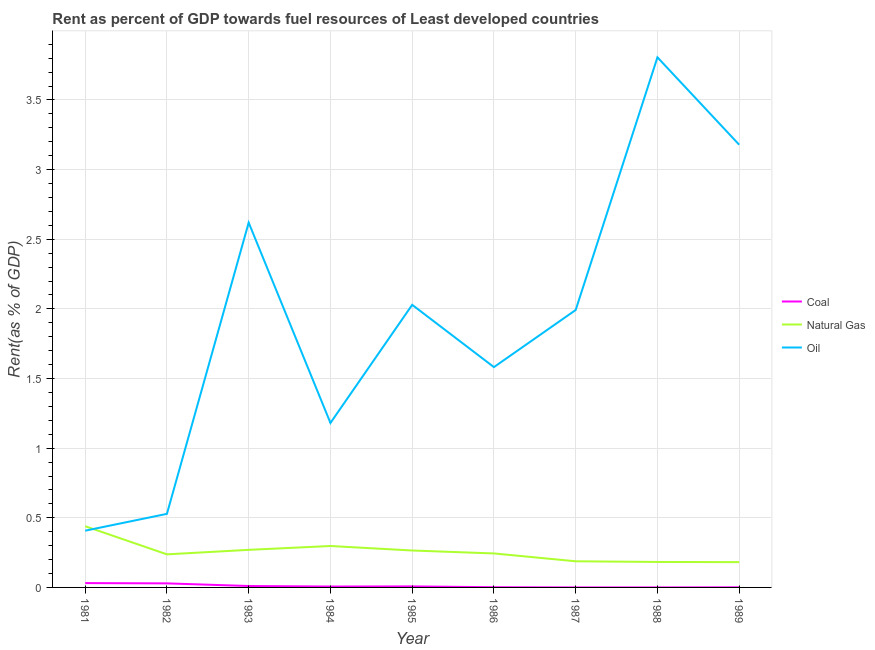How many different coloured lines are there?
Provide a succinct answer. 3. Does the line corresponding to rent towards natural gas intersect with the line corresponding to rent towards coal?
Ensure brevity in your answer.  No. What is the rent towards coal in 1984?
Give a very brief answer. 0.01. Across all years, what is the maximum rent towards coal?
Provide a short and direct response. 0.03. Across all years, what is the minimum rent towards oil?
Ensure brevity in your answer.  0.41. In which year was the rent towards coal maximum?
Keep it short and to the point. 1981. In which year was the rent towards oil minimum?
Your response must be concise. 1981. What is the total rent towards oil in the graph?
Offer a very short reply. 17.32. What is the difference between the rent towards coal in 1982 and that in 1988?
Provide a succinct answer. 0.03. What is the difference between the rent towards coal in 1981 and the rent towards natural gas in 1988?
Your answer should be compact. -0.15. What is the average rent towards natural gas per year?
Your answer should be very brief. 0.26. In the year 1989, what is the difference between the rent towards oil and rent towards natural gas?
Provide a succinct answer. 3. What is the ratio of the rent towards natural gas in 1982 to that in 1989?
Your response must be concise. 1.31. What is the difference between the highest and the second highest rent towards coal?
Offer a terse response. 0. What is the difference between the highest and the lowest rent towards coal?
Your answer should be compact. 0.03. Does the rent towards coal monotonically increase over the years?
Offer a terse response. No. Is the rent towards coal strictly greater than the rent towards natural gas over the years?
Provide a succinct answer. No. How many lines are there?
Make the answer very short. 3. How many years are there in the graph?
Keep it short and to the point. 9. Are the values on the major ticks of Y-axis written in scientific E-notation?
Your answer should be compact. No. Does the graph contain grids?
Give a very brief answer. Yes. Where does the legend appear in the graph?
Ensure brevity in your answer.  Center right. What is the title of the graph?
Give a very brief answer. Rent as percent of GDP towards fuel resources of Least developed countries. What is the label or title of the X-axis?
Offer a very short reply. Year. What is the label or title of the Y-axis?
Provide a short and direct response. Rent(as % of GDP). What is the Rent(as % of GDP) of Coal in 1981?
Your answer should be very brief. 0.03. What is the Rent(as % of GDP) of Natural Gas in 1981?
Ensure brevity in your answer.  0.44. What is the Rent(as % of GDP) of Oil in 1981?
Your response must be concise. 0.41. What is the Rent(as % of GDP) of Coal in 1982?
Your answer should be compact. 0.03. What is the Rent(as % of GDP) of Natural Gas in 1982?
Offer a terse response. 0.24. What is the Rent(as % of GDP) of Oil in 1982?
Provide a short and direct response. 0.53. What is the Rent(as % of GDP) of Coal in 1983?
Your answer should be very brief. 0.01. What is the Rent(as % of GDP) in Natural Gas in 1983?
Make the answer very short. 0.27. What is the Rent(as % of GDP) of Oil in 1983?
Your answer should be compact. 2.62. What is the Rent(as % of GDP) of Coal in 1984?
Provide a short and direct response. 0.01. What is the Rent(as % of GDP) in Natural Gas in 1984?
Your answer should be very brief. 0.3. What is the Rent(as % of GDP) of Oil in 1984?
Offer a very short reply. 1.18. What is the Rent(as % of GDP) of Coal in 1985?
Offer a very short reply. 0.01. What is the Rent(as % of GDP) in Natural Gas in 1985?
Offer a very short reply. 0.27. What is the Rent(as % of GDP) in Oil in 1985?
Your answer should be very brief. 2.03. What is the Rent(as % of GDP) in Coal in 1986?
Make the answer very short. 0. What is the Rent(as % of GDP) of Natural Gas in 1986?
Your answer should be very brief. 0.24. What is the Rent(as % of GDP) in Oil in 1986?
Keep it short and to the point. 1.58. What is the Rent(as % of GDP) of Coal in 1987?
Offer a terse response. 5.84697420507121e-6. What is the Rent(as % of GDP) in Natural Gas in 1987?
Give a very brief answer. 0.19. What is the Rent(as % of GDP) of Oil in 1987?
Your answer should be compact. 1.99. What is the Rent(as % of GDP) of Coal in 1988?
Offer a terse response. 1.03994551316466e-5. What is the Rent(as % of GDP) of Natural Gas in 1988?
Give a very brief answer. 0.18. What is the Rent(as % of GDP) of Oil in 1988?
Your answer should be very brief. 3.81. What is the Rent(as % of GDP) in Coal in 1989?
Ensure brevity in your answer.  0. What is the Rent(as % of GDP) in Natural Gas in 1989?
Provide a short and direct response. 0.18. What is the Rent(as % of GDP) in Oil in 1989?
Your answer should be very brief. 3.18. Across all years, what is the maximum Rent(as % of GDP) of Coal?
Ensure brevity in your answer.  0.03. Across all years, what is the maximum Rent(as % of GDP) of Natural Gas?
Offer a very short reply. 0.44. Across all years, what is the maximum Rent(as % of GDP) in Oil?
Offer a very short reply. 3.81. Across all years, what is the minimum Rent(as % of GDP) of Coal?
Give a very brief answer. 5.84697420507121e-6. Across all years, what is the minimum Rent(as % of GDP) of Natural Gas?
Your response must be concise. 0.18. Across all years, what is the minimum Rent(as % of GDP) of Oil?
Provide a short and direct response. 0.41. What is the total Rent(as % of GDP) of Coal in the graph?
Offer a very short reply. 0.09. What is the total Rent(as % of GDP) of Natural Gas in the graph?
Offer a very short reply. 2.31. What is the total Rent(as % of GDP) of Oil in the graph?
Provide a succinct answer. 17.32. What is the difference between the Rent(as % of GDP) in Coal in 1981 and that in 1982?
Give a very brief answer. 0. What is the difference between the Rent(as % of GDP) in Natural Gas in 1981 and that in 1982?
Make the answer very short. 0.2. What is the difference between the Rent(as % of GDP) of Oil in 1981 and that in 1982?
Provide a succinct answer. -0.12. What is the difference between the Rent(as % of GDP) in Coal in 1981 and that in 1983?
Ensure brevity in your answer.  0.02. What is the difference between the Rent(as % of GDP) of Natural Gas in 1981 and that in 1983?
Your response must be concise. 0.17. What is the difference between the Rent(as % of GDP) in Oil in 1981 and that in 1983?
Offer a very short reply. -2.21. What is the difference between the Rent(as % of GDP) in Coal in 1981 and that in 1984?
Give a very brief answer. 0.02. What is the difference between the Rent(as % of GDP) in Natural Gas in 1981 and that in 1984?
Your response must be concise. 0.14. What is the difference between the Rent(as % of GDP) in Oil in 1981 and that in 1984?
Make the answer very short. -0.77. What is the difference between the Rent(as % of GDP) of Coal in 1981 and that in 1985?
Your answer should be very brief. 0.02. What is the difference between the Rent(as % of GDP) in Natural Gas in 1981 and that in 1985?
Your response must be concise. 0.17. What is the difference between the Rent(as % of GDP) in Oil in 1981 and that in 1985?
Ensure brevity in your answer.  -1.62. What is the difference between the Rent(as % of GDP) in Coal in 1981 and that in 1986?
Provide a succinct answer. 0.03. What is the difference between the Rent(as % of GDP) in Natural Gas in 1981 and that in 1986?
Your answer should be compact. 0.2. What is the difference between the Rent(as % of GDP) of Oil in 1981 and that in 1986?
Give a very brief answer. -1.17. What is the difference between the Rent(as % of GDP) of Coal in 1981 and that in 1987?
Offer a very short reply. 0.03. What is the difference between the Rent(as % of GDP) of Natural Gas in 1981 and that in 1987?
Ensure brevity in your answer.  0.25. What is the difference between the Rent(as % of GDP) of Oil in 1981 and that in 1987?
Offer a very short reply. -1.58. What is the difference between the Rent(as % of GDP) in Coal in 1981 and that in 1988?
Ensure brevity in your answer.  0.03. What is the difference between the Rent(as % of GDP) of Natural Gas in 1981 and that in 1988?
Your response must be concise. 0.26. What is the difference between the Rent(as % of GDP) of Oil in 1981 and that in 1988?
Provide a short and direct response. -3.4. What is the difference between the Rent(as % of GDP) of Coal in 1981 and that in 1989?
Offer a terse response. 0.03. What is the difference between the Rent(as % of GDP) of Natural Gas in 1981 and that in 1989?
Your response must be concise. 0.26. What is the difference between the Rent(as % of GDP) of Oil in 1981 and that in 1989?
Your response must be concise. -2.77. What is the difference between the Rent(as % of GDP) of Coal in 1982 and that in 1983?
Provide a short and direct response. 0.02. What is the difference between the Rent(as % of GDP) in Natural Gas in 1982 and that in 1983?
Offer a terse response. -0.03. What is the difference between the Rent(as % of GDP) of Oil in 1982 and that in 1983?
Offer a very short reply. -2.09. What is the difference between the Rent(as % of GDP) of Coal in 1982 and that in 1984?
Offer a terse response. 0.02. What is the difference between the Rent(as % of GDP) in Natural Gas in 1982 and that in 1984?
Give a very brief answer. -0.06. What is the difference between the Rent(as % of GDP) of Oil in 1982 and that in 1984?
Give a very brief answer. -0.65. What is the difference between the Rent(as % of GDP) of Coal in 1982 and that in 1985?
Your response must be concise. 0.02. What is the difference between the Rent(as % of GDP) in Natural Gas in 1982 and that in 1985?
Give a very brief answer. -0.03. What is the difference between the Rent(as % of GDP) of Oil in 1982 and that in 1985?
Give a very brief answer. -1.5. What is the difference between the Rent(as % of GDP) in Coal in 1982 and that in 1986?
Give a very brief answer. 0.03. What is the difference between the Rent(as % of GDP) in Natural Gas in 1982 and that in 1986?
Offer a very short reply. -0.01. What is the difference between the Rent(as % of GDP) of Oil in 1982 and that in 1986?
Keep it short and to the point. -1.05. What is the difference between the Rent(as % of GDP) of Coal in 1982 and that in 1987?
Provide a short and direct response. 0.03. What is the difference between the Rent(as % of GDP) in Natural Gas in 1982 and that in 1987?
Provide a short and direct response. 0.05. What is the difference between the Rent(as % of GDP) of Oil in 1982 and that in 1987?
Give a very brief answer. -1.46. What is the difference between the Rent(as % of GDP) in Coal in 1982 and that in 1988?
Provide a succinct answer. 0.03. What is the difference between the Rent(as % of GDP) in Natural Gas in 1982 and that in 1988?
Your answer should be very brief. 0.05. What is the difference between the Rent(as % of GDP) of Oil in 1982 and that in 1988?
Keep it short and to the point. -3.28. What is the difference between the Rent(as % of GDP) of Coal in 1982 and that in 1989?
Keep it short and to the point. 0.03. What is the difference between the Rent(as % of GDP) in Natural Gas in 1982 and that in 1989?
Make the answer very short. 0.06. What is the difference between the Rent(as % of GDP) of Oil in 1982 and that in 1989?
Give a very brief answer. -2.65. What is the difference between the Rent(as % of GDP) of Coal in 1983 and that in 1984?
Provide a succinct answer. 0. What is the difference between the Rent(as % of GDP) of Natural Gas in 1983 and that in 1984?
Ensure brevity in your answer.  -0.03. What is the difference between the Rent(as % of GDP) in Oil in 1983 and that in 1984?
Ensure brevity in your answer.  1.44. What is the difference between the Rent(as % of GDP) of Coal in 1983 and that in 1985?
Provide a short and direct response. 0. What is the difference between the Rent(as % of GDP) in Natural Gas in 1983 and that in 1985?
Offer a very short reply. 0. What is the difference between the Rent(as % of GDP) in Oil in 1983 and that in 1985?
Ensure brevity in your answer.  0.59. What is the difference between the Rent(as % of GDP) of Coal in 1983 and that in 1986?
Ensure brevity in your answer.  0.01. What is the difference between the Rent(as % of GDP) in Natural Gas in 1983 and that in 1986?
Give a very brief answer. 0.03. What is the difference between the Rent(as % of GDP) in Oil in 1983 and that in 1986?
Offer a terse response. 1.04. What is the difference between the Rent(as % of GDP) in Coal in 1983 and that in 1987?
Your answer should be compact. 0.01. What is the difference between the Rent(as % of GDP) of Natural Gas in 1983 and that in 1987?
Make the answer very short. 0.08. What is the difference between the Rent(as % of GDP) of Oil in 1983 and that in 1987?
Make the answer very short. 0.63. What is the difference between the Rent(as % of GDP) in Coal in 1983 and that in 1988?
Ensure brevity in your answer.  0.01. What is the difference between the Rent(as % of GDP) in Natural Gas in 1983 and that in 1988?
Your response must be concise. 0.09. What is the difference between the Rent(as % of GDP) of Oil in 1983 and that in 1988?
Offer a very short reply. -1.19. What is the difference between the Rent(as % of GDP) in Coal in 1983 and that in 1989?
Provide a short and direct response. 0.01. What is the difference between the Rent(as % of GDP) in Natural Gas in 1983 and that in 1989?
Offer a very short reply. 0.09. What is the difference between the Rent(as % of GDP) in Oil in 1983 and that in 1989?
Provide a short and direct response. -0.56. What is the difference between the Rent(as % of GDP) of Coal in 1984 and that in 1985?
Provide a short and direct response. -0. What is the difference between the Rent(as % of GDP) in Natural Gas in 1984 and that in 1985?
Ensure brevity in your answer.  0.03. What is the difference between the Rent(as % of GDP) in Oil in 1984 and that in 1985?
Your answer should be very brief. -0.85. What is the difference between the Rent(as % of GDP) in Coal in 1984 and that in 1986?
Offer a very short reply. 0. What is the difference between the Rent(as % of GDP) in Natural Gas in 1984 and that in 1986?
Your answer should be very brief. 0.05. What is the difference between the Rent(as % of GDP) in Oil in 1984 and that in 1986?
Your response must be concise. -0.4. What is the difference between the Rent(as % of GDP) of Coal in 1984 and that in 1987?
Provide a short and direct response. 0.01. What is the difference between the Rent(as % of GDP) in Natural Gas in 1984 and that in 1987?
Make the answer very short. 0.11. What is the difference between the Rent(as % of GDP) of Oil in 1984 and that in 1987?
Your answer should be compact. -0.81. What is the difference between the Rent(as % of GDP) of Coal in 1984 and that in 1988?
Give a very brief answer. 0.01. What is the difference between the Rent(as % of GDP) in Natural Gas in 1984 and that in 1988?
Provide a short and direct response. 0.11. What is the difference between the Rent(as % of GDP) in Oil in 1984 and that in 1988?
Your answer should be very brief. -2.63. What is the difference between the Rent(as % of GDP) of Coal in 1984 and that in 1989?
Make the answer very short. 0.01. What is the difference between the Rent(as % of GDP) in Natural Gas in 1984 and that in 1989?
Your answer should be compact. 0.12. What is the difference between the Rent(as % of GDP) in Oil in 1984 and that in 1989?
Provide a short and direct response. -2. What is the difference between the Rent(as % of GDP) in Coal in 1985 and that in 1986?
Offer a very short reply. 0.01. What is the difference between the Rent(as % of GDP) of Natural Gas in 1985 and that in 1986?
Make the answer very short. 0.02. What is the difference between the Rent(as % of GDP) in Oil in 1985 and that in 1986?
Make the answer very short. 0.45. What is the difference between the Rent(as % of GDP) in Coal in 1985 and that in 1987?
Provide a succinct answer. 0.01. What is the difference between the Rent(as % of GDP) of Natural Gas in 1985 and that in 1987?
Keep it short and to the point. 0.08. What is the difference between the Rent(as % of GDP) in Oil in 1985 and that in 1987?
Provide a succinct answer. 0.04. What is the difference between the Rent(as % of GDP) of Coal in 1985 and that in 1988?
Your answer should be very brief. 0.01. What is the difference between the Rent(as % of GDP) of Natural Gas in 1985 and that in 1988?
Keep it short and to the point. 0.08. What is the difference between the Rent(as % of GDP) of Oil in 1985 and that in 1988?
Offer a very short reply. -1.78. What is the difference between the Rent(as % of GDP) of Coal in 1985 and that in 1989?
Your response must be concise. 0.01. What is the difference between the Rent(as % of GDP) of Natural Gas in 1985 and that in 1989?
Your response must be concise. 0.08. What is the difference between the Rent(as % of GDP) in Oil in 1985 and that in 1989?
Provide a succinct answer. -1.15. What is the difference between the Rent(as % of GDP) in Coal in 1986 and that in 1987?
Keep it short and to the point. 0. What is the difference between the Rent(as % of GDP) of Natural Gas in 1986 and that in 1987?
Your response must be concise. 0.06. What is the difference between the Rent(as % of GDP) of Oil in 1986 and that in 1987?
Offer a very short reply. -0.41. What is the difference between the Rent(as % of GDP) of Coal in 1986 and that in 1988?
Offer a terse response. 0. What is the difference between the Rent(as % of GDP) in Natural Gas in 1986 and that in 1988?
Your answer should be compact. 0.06. What is the difference between the Rent(as % of GDP) of Oil in 1986 and that in 1988?
Offer a very short reply. -2.22. What is the difference between the Rent(as % of GDP) in Coal in 1986 and that in 1989?
Your answer should be very brief. 0. What is the difference between the Rent(as % of GDP) of Natural Gas in 1986 and that in 1989?
Your response must be concise. 0.06. What is the difference between the Rent(as % of GDP) in Oil in 1986 and that in 1989?
Ensure brevity in your answer.  -1.6. What is the difference between the Rent(as % of GDP) of Natural Gas in 1987 and that in 1988?
Your response must be concise. 0. What is the difference between the Rent(as % of GDP) in Oil in 1987 and that in 1988?
Provide a short and direct response. -1.81. What is the difference between the Rent(as % of GDP) in Coal in 1987 and that in 1989?
Provide a short and direct response. -0. What is the difference between the Rent(as % of GDP) in Natural Gas in 1987 and that in 1989?
Offer a terse response. 0.01. What is the difference between the Rent(as % of GDP) of Oil in 1987 and that in 1989?
Offer a terse response. -1.19. What is the difference between the Rent(as % of GDP) of Coal in 1988 and that in 1989?
Ensure brevity in your answer.  -0. What is the difference between the Rent(as % of GDP) in Natural Gas in 1988 and that in 1989?
Keep it short and to the point. 0. What is the difference between the Rent(as % of GDP) of Oil in 1988 and that in 1989?
Give a very brief answer. 0.63. What is the difference between the Rent(as % of GDP) of Coal in 1981 and the Rent(as % of GDP) of Natural Gas in 1982?
Offer a very short reply. -0.21. What is the difference between the Rent(as % of GDP) in Coal in 1981 and the Rent(as % of GDP) in Oil in 1982?
Offer a terse response. -0.5. What is the difference between the Rent(as % of GDP) of Natural Gas in 1981 and the Rent(as % of GDP) of Oil in 1982?
Keep it short and to the point. -0.09. What is the difference between the Rent(as % of GDP) of Coal in 1981 and the Rent(as % of GDP) of Natural Gas in 1983?
Offer a very short reply. -0.24. What is the difference between the Rent(as % of GDP) in Coal in 1981 and the Rent(as % of GDP) in Oil in 1983?
Provide a succinct answer. -2.59. What is the difference between the Rent(as % of GDP) in Natural Gas in 1981 and the Rent(as % of GDP) in Oil in 1983?
Your answer should be very brief. -2.18. What is the difference between the Rent(as % of GDP) of Coal in 1981 and the Rent(as % of GDP) of Natural Gas in 1984?
Provide a short and direct response. -0.27. What is the difference between the Rent(as % of GDP) in Coal in 1981 and the Rent(as % of GDP) in Oil in 1984?
Offer a terse response. -1.15. What is the difference between the Rent(as % of GDP) of Natural Gas in 1981 and the Rent(as % of GDP) of Oil in 1984?
Your answer should be very brief. -0.74. What is the difference between the Rent(as % of GDP) in Coal in 1981 and the Rent(as % of GDP) in Natural Gas in 1985?
Provide a short and direct response. -0.23. What is the difference between the Rent(as % of GDP) in Coal in 1981 and the Rent(as % of GDP) in Oil in 1985?
Your answer should be very brief. -2. What is the difference between the Rent(as % of GDP) of Natural Gas in 1981 and the Rent(as % of GDP) of Oil in 1985?
Your answer should be very brief. -1.59. What is the difference between the Rent(as % of GDP) of Coal in 1981 and the Rent(as % of GDP) of Natural Gas in 1986?
Give a very brief answer. -0.21. What is the difference between the Rent(as % of GDP) of Coal in 1981 and the Rent(as % of GDP) of Oil in 1986?
Your answer should be compact. -1.55. What is the difference between the Rent(as % of GDP) in Natural Gas in 1981 and the Rent(as % of GDP) in Oil in 1986?
Provide a short and direct response. -1.14. What is the difference between the Rent(as % of GDP) in Coal in 1981 and the Rent(as % of GDP) in Natural Gas in 1987?
Your answer should be very brief. -0.16. What is the difference between the Rent(as % of GDP) in Coal in 1981 and the Rent(as % of GDP) in Oil in 1987?
Provide a short and direct response. -1.96. What is the difference between the Rent(as % of GDP) in Natural Gas in 1981 and the Rent(as % of GDP) in Oil in 1987?
Provide a succinct answer. -1.55. What is the difference between the Rent(as % of GDP) in Coal in 1981 and the Rent(as % of GDP) in Natural Gas in 1988?
Keep it short and to the point. -0.15. What is the difference between the Rent(as % of GDP) in Coal in 1981 and the Rent(as % of GDP) in Oil in 1988?
Keep it short and to the point. -3.77. What is the difference between the Rent(as % of GDP) in Natural Gas in 1981 and the Rent(as % of GDP) in Oil in 1988?
Provide a succinct answer. -3.37. What is the difference between the Rent(as % of GDP) of Coal in 1981 and the Rent(as % of GDP) of Natural Gas in 1989?
Your answer should be very brief. -0.15. What is the difference between the Rent(as % of GDP) of Coal in 1981 and the Rent(as % of GDP) of Oil in 1989?
Keep it short and to the point. -3.15. What is the difference between the Rent(as % of GDP) in Natural Gas in 1981 and the Rent(as % of GDP) in Oil in 1989?
Make the answer very short. -2.74. What is the difference between the Rent(as % of GDP) in Coal in 1982 and the Rent(as % of GDP) in Natural Gas in 1983?
Provide a short and direct response. -0.24. What is the difference between the Rent(as % of GDP) of Coal in 1982 and the Rent(as % of GDP) of Oil in 1983?
Keep it short and to the point. -2.59. What is the difference between the Rent(as % of GDP) of Natural Gas in 1982 and the Rent(as % of GDP) of Oil in 1983?
Your answer should be compact. -2.38. What is the difference between the Rent(as % of GDP) of Coal in 1982 and the Rent(as % of GDP) of Natural Gas in 1984?
Ensure brevity in your answer.  -0.27. What is the difference between the Rent(as % of GDP) of Coal in 1982 and the Rent(as % of GDP) of Oil in 1984?
Your answer should be compact. -1.15. What is the difference between the Rent(as % of GDP) in Natural Gas in 1982 and the Rent(as % of GDP) in Oil in 1984?
Your answer should be compact. -0.94. What is the difference between the Rent(as % of GDP) of Coal in 1982 and the Rent(as % of GDP) of Natural Gas in 1985?
Your answer should be compact. -0.24. What is the difference between the Rent(as % of GDP) of Coal in 1982 and the Rent(as % of GDP) of Oil in 1985?
Offer a terse response. -2. What is the difference between the Rent(as % of GDP) in Natural Gas in 1982 and the Rent(as % of GDP) in Oil in 1985?
Give a very brief answer. -1.79. What is the difference between the Rent(as % of GDP) of Coal in 1982 and the Rent(as % of GDP) of Natural Gas in 1986?
Give a very brief answer. -0.21. What is the difference between the Rent(as % of GDP) of Coal in 1982 and the Rent(as % of GDP) of Oil in 1986?
Your answer should be compact. -1.55. What is the difference between the Rent(as % of GDP) in Natural Gas in 1982 and the Rent(as % of GDP) in Oil in 1986?
Your response must be concise. -1.34. What is the difference between the Rent(as % of GDP) of Coal in 1982 and the Rent(as % of GDP) of Natural Gas in 1987?
Your answer should be very brief. -0.16. What is the difference between the Rent(as % of GDP) of Coal in 1982 and the Rent(as % of GDP) of Oil in 1987?
Offer a very short reply. -1.96. What is the difference between the Rent(as % of GDP) in Natural Gas in 1982 and the Rent(as % of GDP) in Oil in 1987?
Your response must be concise. -1.75. What is the difference between the Rent(as % of GDP) in Coal in 1982 and the Rent(as % of GDP) in Natural Gas in 1988?
Provide a short and direct response. -0.15. What is the difference between the Rent(as % of GDP) of Coal in 1982 and the Rent(as % of GDP) of Oil in 1988?
Make the answer very short. -3.78. What is the difference between the Rent(as % of GDP) in Natural Gas in 1982 and the Rent(as % of GDP) in Oil in 1988?
Make the answer very short. -3.57. What is the difference between the Rent(as % of GDP) of Coal in 1982 and the Rent(as % of GDP) of Natural Gas in 1989?
Your answer should be very brief. -0.15. What is the difference between the Rent(as % of GDP) in Coal in 1982 and the Rent(as % of GDP) in Oil in 1989?
Your response must be concise. -3.15. What is the difference between the Rent(as % of GDP) in Natural Gas in 1982 and the Rent(as % of GDP) in Oil in 1989?
Give a very brief answer. -2.94. What is the difference between the Rent(as % of GDP) of Coal in 1983 and the Rent(as % of GDP) of Natural Gas in 1984?
Your response must be concise. -0.29. What is the difference between the Rent(as % of GDP) of Coal in 1983 and the Rent(as % of GDP) of Oil in 1984?
Provide a short and direct response. -1.17. What is the difference between the Rent(as % of GDP) in Natural Gas in 1983 and the Rent(as % of GDP) in Oil in 1984?
Your answer should be very brief. -0.91. What is the difference between the Rent(as % of GDP) in Coal in 1983 and the Rent(as % of GDP) in Natural Gas in 1985?
Provide a succinct answer. -0.26. What is the difference between the Rent(as % of GDP) in Coal in 1983 and the Rent(as % of GDP) in Oil in 1985?
Give a very brief answer. -2.02. What is the difference between the Rent(as % of GDP) in Natural Gas in 1983 and the Rent(as % of GDP) in Oil in 1985?
Give a very brief answer. -1.76. What is the difference between the Rent(as % of GDP) of Coal in 1983 and the Rent(as % of GDP) of Natural Gas in 1986?
Offer a very short reply. -0.23. What is the difference between the Rent(as % of GDP) of Coal in 1983 and the Rent(as % of GDP) of Oil in 1986?
Make the answer very short. -1.57. What is the difference between the Rent(as % of GDP) of Natural Gas in 1983 and the Rent(as % of GDP) of Oil in 1986?
Offer a very short reply. -1.31. What is the difference between the Rent(as % of GDP) of Coal in 1983 and the Rent(as % of GDP) of Natural Gas in 1987?
Give a very brief answer. -0.18. What is the difference between the Rent(as % of GDP) of Coal in 1983 and the Rent(as % of GDP) of Oil in 1987?
Ensure brevity in your answer.  -1.98. What is the difference between the Rent(as % of GDP) of Natural Gas in 1983 and the Rent(as % of GDP) of Oil in 1987?
Provide a short and direct response. -1.72. What is the difference between the Rent(as % of GDP) in Coal in 1983 and the Rent(as % of GDP) in Natural Gas in 1988?
Keep it short and to the point. -0.17. What is the difference between the Rent(as % of GDP) of Coal in 1983 and the Rent(as % of GDP) of Oil in 1988?
Your answer should be very brief. -3.8. What is the difference between the Rent(as % of GDP) in Natural Gas in 1983 and the Rent(as % of GDP) in Oil in 1988?
Your answer should be compact. -3.54. What is the difference between the Rent(as % of GDP) in Coal in 1983 and the Rent(as % of GDP) in Natural Gas in 1989?
Offer a terse response. -0.17. What is the difference between the Rent(as % of GDP) in Coal in 1983 and the Rent(as % of GDP) in Oil in 1989?
Offer a very short reply. -3.17. What is the difference between the Rent(as % of GDP) of Natural Gas in 1983 and the Rent(as % of GDP) of Oil in 1989?
Give a very brief answer. -2.91. What is the difference between the Rent(as % of GDP) in Coal in 1984 and the Rent(as % of GDP) in Natural Gas in 1985?
Give a very brief answer. -0.26. What is the difference between the Rent(as % of GDP) in Coal in 1984 and the Rent(as % of GDP) in Oil in 1985?
Ensure brevity in your answer.  -2.02. What is the difference between the Rent(as % of GDP) of Natural Gas in 1984 and the Rent(as % of GDP) of Oil in 1985?
Make the answer very short. -1.73. What is the difference between the Rent(as % of GDP) in Coal in 1984 and the Rent(as % of GDP) in Natural Gas in 1986?
Provide a short and direct response. -0.24. What is the difference between the Rent(as % of GDP) in Coal in 1984 and the Rent(as % of GDP) in Oil in 1986?
Provide a succinct answer. -1.58. What is the difference between the Rent(as % of GDP) in Natural Gas in 1984 and the Rent(as % of GDP) in Oil in 1986?
Your response must be concise. -1.28. What is the difference between the Rent(as % of GDP) of Coal in 1984 and the Rent(as % of GDP) of Natural Gas in 1987?
Your response must be concise. -0.18. What is the difference between the Rent(as % of GDP) of Coal in 1984 and the Rent(as % of GDP) of Oil in 1987?
Your answer should be very brief. -1.99. What is the difference between the Rent(as % of GDP) in Natural Gas in 1984 and the Rent(as % of GDP) in Oil in 1987?
Your response must be concise. -1.69. What is the difference between the Rent(as % of GDP) in Coal in 1984 and the Rent(as % of GDP) in Natural Gas in 1988?
Provide a succinct answer. -0.18. What is the difference between the Rent(as % of GDP) of Coal in 1984 and the Rent(as % of GDP) of Oil in 1988?
Give a very brief answer. -3.8. What is the difference between the Rent(as % of GDP) in Natural Gas in 1984 and the Rent(as % of GDP) in Oil in 1988?
Provide a short and direct response. -3.51. What is the difference between the Rent(as % of GDP) of Coal in 1984 and the Rent(as % of GDP) of Natural Gas in 1989?
Keep it short and to the point. -0.18. What is the difference between the Rent(as % of GDP) of Coal in 1984 and the Rent(as % of GDP) of Oil in 1989?
Keep it short and to the point. -3.17. What is the difference between the Rent(as % of GDP) in Natural Gas in 1984 and the Rent(as % of GDP) in Oil in 1989?
Provide a succinct answer. -2.88. What is the difference between the Rent(as % of GDP) of Coal in 1985 and the Rent(as % of GDP) of Natural Gas in 1986?
Provide a succinct answer. -0.24. What is the difference between the Rent(as % of GDP) in Coal in 1985 and the Rent(as % of GDP) in Oil in 1986?
Your answer should be compact. -1.57. What is the difference between the Rent(as % of GDP) of Natural Gas in 1985 and the Rent(as % of GDP) of Oil in 1986?
Your response must be concise. -1.32. What is the difference between the Rent(as % of GDP) of Coal in 1985 and the Rent(as % of GDP) of Natural Gas in 1987?
Provide a succinct answer. -0.18. What is the difference between the Rent(as % of GDP) in Coal in 1985 and the Rent(as % of GDP) in Oil in 1987?
Give a very brief answer. -1.98. What is the difference between the Rent(as % of GDP) in Natural Gas in 1985 and the Rent(as % of GDP) in Oil in 1987?
Keep it short and to the point. -1.73. What is the difference between the Rent(as % of GDP) of Coal in 1985 and the Rent(as % of GDP) of Natural Gas in 1988?
Your answer should be very brief. -0.18. What is the difference between the Rent(as % of GDP) in Coal in 1985 and the Rent(as % of GDP) in Oil in 1988?
Give a very brief answer. -3.8. What is the difference between the Rent(as % of GDP) in Natural Gas in 1985 and the Rent(as % of GDP) in Oil in 1988?
Your response must be concise. -3.54. What is the difference between the Rent(as % of GDP) in Coal in 1985 and the Rent(as % of GDP) in Natural Gas in 1989?
Offer a very short reply. -0.17. What is the difference between the Rent(as % of GDP) in Coal in 1985 and the Rent(as % of GDP) in Oil in 1989?
Keep it short and to the point. -3.17. What is the difference between the Rent(as % of GDP) of Natural Gas in 1985 and the Rent(as % of GDP) of Oil in 1989?
Ensure brevity in your answer.  -2.91. What is the difference between the Rent(as % of GDP) of Coal in 1986 and the Rent(as % of GDP) of Natural Gas in 1987?
Offer a very short reply. -0.19. What is the difference between the Rent(as % of GDP) of Coal in 1986 and the Rent(as % of GDP) of Oil in 1987?
Keep it short and to the point. -1.99. What is the difference between the Rent(as % of GDP) in Natural Gas in 1986 and the Rent(as % of GDP) in Oil in 1987?
Offer a very short reply. -1.75. What is the difference between the Rent(as % of GDP) in Coal in 1986 and the Rent(as % of GDP) in Natural Gas in 1988?
Your answer should be compact. -0.18. What is the difference between the Rent(as % of GDP) of Coal in 1986 and the Rent(as % of GDP) of Oil in 1988?
Keep it short and to the point. -3.8. What is the difference between the Rent(as % of GDP) in Natural Gas in 1986 and the Rent(as % of GDP) in Oil in 1988?
Offer a very short reply. -3.56. What is the difference between the Rent(as % of GDP) of Coal in 1986 and the Rent(as % of GDP) of Natural Gas in 1989?
Provide a short and direct response. -0.18. What is the difference between the Rent(as % of GDP) in Coal in 1986 and the Rent(as % of GDP) in Oil in 1989?
Ensure brevity in your answer.  -3.18. What is the difference between the Rent(as % of GDP) of Natural Gas in 1986 and the Rent(as % of GDP) of Oil in 1989?
Your response must be concise. -2.93. What is the difference between the Rent(as % of GDP) in Coal in 1987 and the Rent(as % of GDP) in Natural Gas in 1988?
Keep it short and to the point. -0.18. What is the difference between the Rent(as % of GDP) in Coal in 1987 and the Rent(as % of GDP) in Oil in 1988?
Keep it short and to the point. -3.81. What is the difference between the Rent(as % of GDP) of Natural Gas in 1987 and the Rent(as % of GDP) of Oil in 1988?
Your answer should be compact. -3.62. What is the difference between the Rent(as % of GDP) in Coal in 1987 and the Rent(as % of GDP) in Natural Gas in 1989?
Offer a very short reply. -0.18. What is the difference between the Rent(as % of GDP) of Coal in 1987 and the Rent(as % of GDP) of Oil in 1989?
Your answer should be compact. -3.18. What is the difference between the Rent(as % of GDP) in Natural Gas in 1987 and the Rent(as % of GDP) in Oil in 1989?
Give a very brief answer. -2.99. What is the difference between the Rent(as % of GDP) in Coal in 1988 and the Rent(as % of GDP) in Natural Gas in 1989?
Offer a very short reply. -0.18. What is the difference between the Rent(as % of GDP) of Coal in 1988 and the Rent(as % of GDP) of Oil in 1989?
Ensure brevity in your answer.  -3.18. What is the difference between the Rent(as % of GDP) of Natural Gas in 1988 and the Rent(as % of GDP) of Oil in 1989?
Your response must be concise. -3. What is the average Rent(as % of GDP) of Coal per year?
Ensure brevity in your answer.  0.01. What is the average Rent(as % of GDP) of Natural Gas per year?
Give a very brief answer. 0.26. What is the average Rent(as % of GDP) in Oil per year?
Your answer should be very brief. 1.92. In the year 1981, what is the difference between the Rent(as % of GDP) in Coal and Rent(as % of GDP) in Natural Gas?
Your answer should be compact. -0.41. In the year 1981, what is the difference between the Rent(as % of GDP) in Coal and Rent(as % of GDP) in Oil?
Your answer should be compact. -0.38. In the year 1981, what is the difference between the Rent(as % of GDP) of Natural Gas and Rent(as % of GDP) of Oil?
Provide a short and direct response. 0.03. In the year 1982, what is the difference between the Rent(as % of GDP) of Coal and Rent(as % of GDP) of Natural Gas?
Provide a short and direct response. -0.21. In the year 1982, what is the difference between the Rent(as % of GDP) of Coal and Rent(as % of GDP) of Oil?
Offer a terse response. -0.5. In the year 1982, what is the difference between the Rent(as % of GDP) in Natural Gas and Rent(as % of GDP) in Oil?
Provide a succinct answer. -0.29. In the year 1983, what is the difference between the Rent(as % of GDP) in Coal and Rent(as % of GDP) in Natural Gas?
Keep it short and to the point. -0.26. In the year 1983, what is the difference between the Rent(as % of GDP) in Coal and Rent(as % of GDP) in Oil?
Offer a very short reply. -2.61. In the year 1983, what is the difference between the Rent(as % of GDP) in Natural Gas and Rent(as % of GDP) in Oil?
Make the answer very short. -2.35. In the year 1984, what is the difference between the Rent(as % of GDP) of Coal and Rent(as % of GDP) of Natural Gas?
Your answer should be compact. -0.29. In the year 1984, what is the difference between the Rent(as % of GDP) of Coal and Rent(as % of GDP) of Oil?
Your answer should be compact. -1.17. In the year 1984, what is the difference between the Rent(as % of GDP) of Natural Gas and Rent(as % of GDP) of Oil?
Provide a succinct answer. -0.88. In the year 1985, what is the difference between the Rent(as % of GDP) in Coal and Rent(as % of GDP) in Natural Gas?
Provide a short and direct response. -0.26. In the year 1985, what is the difference between the Rent(as % of GDP) of Coal and Rent(as % of GDP) of Oil?
Provide a short and direct response. -2.02. In the year 1985, what is the difference between the Rent(as % of GDP) of Natural Gas and Rent(as % of GDP) of Oil?
Your answer should be compact. -1.76. In the year 1986, what is the difference between the Rent(as % of GDP) of Coal and Rent(as % of GDP) of Natural Gas?
Your response must be concise. -0.24. In the year 1986, what is the difference between the Rent(as % of GDP) in Coal and Rent(as % of GDP) in Oil?
Provide a short and direct response. -1.58. In the year 1986, what is the difference between the Rent(as % of GDP) of Natural Gas and Rent(as % of GDP) of Oil?
Your response must be concise. -1.34. In the year 1987, what is the difference between the Rent(as % of GDP) in Coal and Rent(as % of GDP) in Natural Gas?
Your answer should be compact. -0.19. In the year 1987, what is the difference between the Rent(as % of GDP) in Coal and Rent(as % of GDP) in Oil?
Provide a succinct answer. -1.99. In the year 1987, what is the difference between the Rent(as % of GDP) of Natural Gas and Rent(as % of GDP) of Oil?
Offer a terse response. -1.8. In the year 1988, what is the difference between the Rent(as % of GDP) of Coal and Rent(as % of GDP) of Natural Gas?
Provide a succinct answer. -0.18. In the year 1988, what is the difference between the Rent(as % of GDP) of Coal and Rent(as % of GDP) of Oil?
Make the answer very short. -3.81. In the year 1988, what is the difference between the Rent(as % of GDP) of Natural Gas and Rent(as % of GDP) of Oil?
Provide a short and direct response. -3.62. In the year 1989, what is the difference between the Rent(as % of GDP) of Coal and Rent(as % of GDP) of Natural Gas?
Offer a very short reply. -0.18. In the year 1989, what is the difference between the Rent(as % of GDP) of Coal and Rent(as % of GDP) of Oil?
Provide a short and direct response. -3.18. In the year 1989, what is the difference between the Rent(as % of GDP) in Natural Gas and Rent(as % of GDP) in Oil?
Provide a short and direct response. -3. What is the ratio of the Rent(as % of GDP) in Coal in 1981 to that in 1982?
Make the answer very short. 1.07. What is the ratio of the Rent(as % of GDP) in Natural Gas in 1981 to that in 1982?
Your answer should be compact. 1.85. What is the ratio of the Rent(as % of GDP) in Oil in 1981 to that in 1982?
Your response must be concise. 0.77. What is the ratio of the Rent(as % of GDP) in Coal in 1981 to that in 1983?
Provide a short and direct response. 3.06. What is the ratio of the Rent(as % of GDP) in Natural Gas in 1981 to that in 1983?
Provide a short and direct response. 1.63. What is the ratio of the Rent(as % of GDP) of Oil in 1981 to that in 1983?
Offer a terse response. 0.16. What is the ratio of the Rent(as % of GDP) of Coal in 1981 to that in 1984?
Provide a succinct answer. 4.89. What is the ratio of the Rent(as % of GDP) of Natural Gas in 1981 to that in 1984?
Give a very brief answer. 1.48. What is the ratio of the Rent(as % of GDP) of Oil in 1981 to that in 1984?
Give a very brief answer. 0.34. What is the ratio of the Rent(as % of GDP) in Coal in 1981 to that in 1985?
Your answer should be very brief. 4.21. What is the ratio of the Rent(as % of GDP) of Natural Gas in 1981 to that in 1985?
Offer a terse response. 1.66. What is the ratio of the Rent(as % of GDP) of Oil in 1981 to that in 1985?
Make the answer very short. 0.2. What is the ratio of the Rent(as % of GDP) in Coal in 1981 to that in 1986?
Offer a very short reply. 20.62. What is the ratio of the Rent(as % of GDP) of Natural Gas in 1981 to that in 1986?
Your answer should be compact. 1.8. What is the ratio of the Rent(as % of GDP) in Oil in 1981 to that in 1986?
Your answer should be compact. 0.26. What is the ratio of the Rent(as % of GDP) in Coal in 1981 to that in 1987?
Offer a very short reply. 5313.62. What is the ratio of the Rent(as % of GDP) in Natural Gas in 1981 to that in 1987?
Your response must be concise. 2.34. What is the ratio of the Rent(as % of GDP) in Oil in 1981 to that in 1987?
Your answer should be compact. 0.2. What is the ratio of the Rent(as % of GDP) in Coal in 1981 to that in 1988?
Make the answer very short. 2987.52. What is the ratio of the Rent(as % of GDP) of Natural Gas in 1981 to that in 1988?
Make the answer very short. 2.4. What is the ratio of the Rent(as % of GDP) in Oil in 1981 to that in 1988?
Provide a short and direct response. 0.11. What is the ratio of the Rent(as % of GDP) of Coal in 1981 to that in 1989?
Your response must be concise. 39.78. What is the ratio of the Rent(as % of GDP) in Natural Gas in 1981 to that in 1989?
Keep it short and to the point. 2.42. What is the ratio of the Rent(as % of GDP) in Oil in 1981 to that in 1989?
Make the answer very short. 0.13. What is the ratio of the Rent(as % of GDP) of Coal in 1982 to that in 1983?
Your answer should be compact. 2.86. What is the ratio of the Rent(as % of GDP) of Natural Gas in 1982 to that in 1983?
Give a very brief answer. 0.88. What is the ratio of the Rent(as % of GDP) of Oil in 1982 to that in 1983?
Keep it short and to the point. 0.2. What is the ratio of the Rent(as % of GDP) of Coal in 1982 to that in 1984?
Ensure brevity in your answer.  4.57. What is the ratio of the Rent(as % of GDP) of Natural Gas in 1982 to that in 1984?
Offer a very short reply. 0.8. What is the ratio of the Rent(as % of GDP) in Oil in 1982 to that in 1984?
Offer a very short reply. 0.45. What is the ratio of the Rent(as % of GDP) in Coal in 1982 to that in 1985?
Provide a succinct answer. 3.94. What is the ratio of the Rent(as % of GDP) of Natural Gas in 1982 to that in 1985?
Offer a terse response. 0.9. What is the ratio of the Rent(as % of GDP) of Oil in 1982 to that in 1985?
Give a very brief answer. 0.26. What is the ratio of the Rent(as % of GDP) of Coal in 1982 to that in 1986?
Make the answer very short. 19.28. What is the ratio of the Rent(as % of GDP) of Natural Gas in 1982 to that in 1986?
Offer a very short reply. 0.97. What is the ratio of the Rent(as % of GDP) of Oil in 1982 to that in 1986?
Keep it short and to the point. 0.33. What is the ratio of the Rent(as % of GDP) of Coal in 1982 to that in 1987?
Your answer should be very brief. 4967.44. What is the ratio of the Rent(as % of GDP) of Natural Gas in 1982 to that in 1987?
Your answer should be very brief. 1.27. What is the ratio of the Rent(as % of GDP) in Oil in 1982 to that in 1987?
Ensure brevity in your answer.  0.27. What is the ratio of the Rent(as % of GDP) in Coal in 1982 to that in 1988?
Offer a very short reply. 2792.89. What is the ratio of the Rent(as % of GDP) in Natural Gas in 1982 to that in 1988?
Your response must be concise. 1.3. What is the ratio of the Rent(as % of GDP) in Oil in 1982 to that in 1988?
Provide a succinct answer. 0.14. What is the ratio of the Rent(as % of GDP) in Coal in 1982 to that in 1989?
Your answer should be very brief. 37.19. What is the ratio of the Rent(as % of GDP) in Natural Gas in 1982 to that in 1989?
Keep it short and to the point. 1.31. What is the ratio of the Rent(as % of GDP) in Oil in 1982 to that in 1989?
Offer a very short reply. 0.17. What is the ratio of the Rent(as % of GDP) of Coal in 1983 to that in 1984?
Offer a very short reply. 1.6. What is the ratio of the Rent(as % of GDP) of Natural Gas in 1983 to that in 1984?
Provide a short and direct response. 0.91. What is the ratio of the Rent(as % of GDP) in Oil in 1983 to that in 1984?
Ensure brevity in your answer.  2.22. What is the ratio of the Rent(as % of GDP) in Coal in 1983 to that in 1985?
Your answer should be compact. 1.37. What is the ratio of the Rent(as % of GDP) in Natural Gas in 1983 to that in 1985?
Offer a terse response. 1.02. What is the ratio of the Rent(as % of GDP) in Oil in 1983 to that in 1985?
Keep it short and to the point. 1.29. What is the ratio of the Rent(as % of GDP) in Coal in 1983 to that in 1986?
Ensure brevity in your answer.  6.73. What is the ratio of the Rent(as % of GDP) in Natural Gas in 1983 to that in 1986?
Provide a short and direct response. 1.11. What is the ratio of the Rent(as % of GDP) in Oil in 1983 to that in 1986?
Keep it short and to the point. 1.66. What is the ratio of the Rent(as % of GDP) of Coal in 1983 to that in 1987?
Your answer should be very brief. 1735.19. What is the ratio of the Rent(as % of GDP) in Natural Gas in 1983 to that in 1987?
Give a very brief answer. 1.44. What is the ratio of the Rent(as % of GDP) of Oil in 1983 to that in 1987?
Provide a short and direct response. 1.31. What is the ratio of the Rent(as % of GDP) of Coal in 1983 to that in 1988?
Make the answer very short. 975.59. What is the ratio of the Rent(as % of GDP) in Natural Gas in 1983 to that in 1988?
Provide a short and direct response. 1.48. What is the ratio of the Rent(as % of GDP) in Oil in 1983 to that in 1988?
Keep it short and to the point. 0.69. What is the ratio of the Rent(as % of GDP) of Coal in 1983 to that in 1989?
Ensure brevity in your answer.  12.99. What is the ratio of the Rent(as % of GDP) of Natural Gas in 1983 to that in 1989?
Your answer should be very brief. 1.49. What is the ratio of the Rent(as % of GDP) in Oil in 1983 to that in 1989?
Give a very brief answer. 0.82. What is the ratio of the Rent(as % of GDP) in Coal in 1984 to that in 1985?
Offer a very short reply. 0.86. What is the ratio of the Rent(as % of GDP) in Natural Gas in 1984 to that in 1985?
Your answer should be very brief. 1.12. What is the ratio of the Rent(as % of GDP) of Oil in 1984 to that in 1985?
Your response must be concise. 0.58. What is the ratio of the Rent(as % of GDP) in Coal in 1984 to that in 1986?
Provide a short and direct response. 4.21. What is the ratio of the Rent(as % of GDP) of Natural Gas in 1984 to that in 1986?
Make the answer very short. 1.22. What is the ratio of the Rent(as % of GDP) in Oil in 1984 to that in 1986?
Your answer should be compact. 0.75. What is the ratio of the Rent(as % of GDP) of Coal in 1984 to that in 1987?
Keep it short and to the point. 1085.94. What is the ratio of the Rent(as % of GDP) of Natural Gas in 1984 to that in 1987?
Give a very brief answer. 1.58. What is the ratio of the Rent(as % of GDP) in Oil in 1984 to that in 1987?
Ensure brevity in your answer.  0.59. What is the ratio of the Rent(as % of GDP) of Coal in 1984 to that in 1988?
Provide a short and direct response. 610.56. What is the ratio of the Rent(as % of GDP) in Natural Gas in 1984 to that in 1988?
Your answer should be very brief. 1.63. What is the ratio of the Rent(as % of GDP) in Oil in 1984 to that in 1988?
Your response must be concise. 0.31. What is the ratio of the Rent(as % of GDP) of Coal in 1984 to that in 1989?
Keep it short and to the point. 8.13. What is the ratio of the Rent(as % of GDP) of Natural Gas in 1984 to that in 1989?
Your answer should be compact. 1.64. What is the ratio of the Rent(as % of GDP) in Oil in 1984 to that in 1989?
Your answer should be compact. 0.37. What is the ratio of the Rent(as % of GDP) in Coal in 1985 to that in 1986?
Your answer should be very brief. 4.9. What is the ratio of the Rent(as % of GDP) of Natural Gas in 1985 to that in 1986?
Your answer should be very brief. 1.09. What is the ratio of the Rent(as % of GDP) in Oil in 1985 to that in 1986?
Provide a short and direct response. 1.28. What is the ratio of the Rent(as % of GDP) in Coal in 1985 to that in 1987?
Offer a terse response. 1262.16. What is the ratio of the Rent(as % of GDP) of Natural Gas in 1985 to that in 1987?
Offer a very short reply. 1.41. What is the ratio of the Rent(as % of GDP) of Oil in 1985 to that in 1987?
Offer a terse response. 1.02. What is the ratio of the Rent(as % of GDP) in Coal in 1985 to that in 1988?
Provide a short and direct response. 709.63. What is the ratio of the Rent(as % of GDP) in Natural Gas in 1985 to that in 1988?
Ensure brevity in your answer.  1.45. What is the ratio of the Rent(as % of GDP) of Oil in 1985 to that in 1988?
Keep it short and to the point. 0.53. What is the ratio of the Rent(as % of GDP) in Coal in 1985 to that in 1989?
Provide a succinct answer. 9.45. What is the ratio of the Rent(as % of GDP) of Natural Gas in 1985 to that in 1989?
Provide a succinct answer. 1.46. What is the ratio of the Rent(as % of GDP) of Oil in 1985 to that in 1989?
Give a very brief answer. 0.64. What is the ratio of the Rent(as % of GDP) in Coal in 1986 to that in 1987?
Give a very brief answer. 257.66. What is the ratio of the Rent(as % of GDP) in Natural Gas in 1986 to that in 1987?
Make the answer very short. 1.3. What is the ratio of the Rent(as % of GDP) in Oil in 1986 to that in 1987?
Offer a terse response. 0.79. What is the ratio of the Rent(as % of GDP) in Coal in 1986 to that in 1988?
Your response must be concise. 144.86. What is the ratio of the Rent(as % of GDP) in Natural Gas in 1986 to that in 1988?
Give a very brief answer. 1.33. What is the ratio of the Rent(as % of GDP) of Oil in 1986 to that in 1988?
Offer a very short reply. 0.42. What is the ratio of the Rent(as % of GDP) in Coal in 1986 to that in 1989?
Offer a terse response. 1.93. What is the ratio of the Rent(as % of GDP) of Natural Gas in 1986 to that in 1989?
Offer a very short reply. 1.34. What is the ratio of the Rent(as % of GDP) in Oil in 1986 to that in 1989?
Keep it short and to the point. 0.5. What is the ratio of the Rent(as % of GDP) of Coal in 1987 to that in 1988?
Offer a very short reply. 0.56. What is the ratio of the Rent(as % of GDP) in Natural Gas in 1987 to that in 1988?
Provide a succinct answer. 1.03. What is the ratio of the Rent(as % of GDP) of Oil in 1987 to that in 1988?
Give a very brief answer. 0.52. What is the ratio of the Rent(as % of GDP) of Coal in 1987 to that in 1989?
Make the answer very short. 0.01. What is the ratio of the Rent(as % of GDP) in Natural Gas in 1987 to that in 1989?
Your response must be concise. 1.03. What is the ratio of the Rent(as % of GDP) in Oil in 1987 to that in 1989?
Your response must be concise. 0.63. What is the ratio of the Rent(as % of GDP) in Coal in 1988 to that in 1989?
Your response must be concise. 0.01. What is the ratio of the Rent(as % of GDP) in Natural Gas in 1988 to that in 1989?
Offer a very short reply. 1.01. What is the ratio of the Rent(as % of GDP) in Oil in 1988 to that in 1989?
Give a very brief answer. 1.2. What is the difference between the highest and the second highest Rent(as % of GDP) in Coal?
Provide a succinct answer. 0. What is the difference between the highest and the second highest Rent(as % of GDP) of Natural Gas?
Your answer should be very brief. 0.14. What is the difference between the highest and the second highest Rent(as % of GDP) in Oil?
Keep it short and to the point. 0.63. What is the difference between the highest and the lowest Rent(as % of GDP) in Coal?
Your answer should be very brief. 0.03. What is the difference between the highest and the lowest Rent(as % of GDP) in Natural Gas?
Make the answer very short. 0.26. What is the difference between the highest and the lowest Rent(as % of GDP) of Oil?
Make the answer very short. 3.4. 